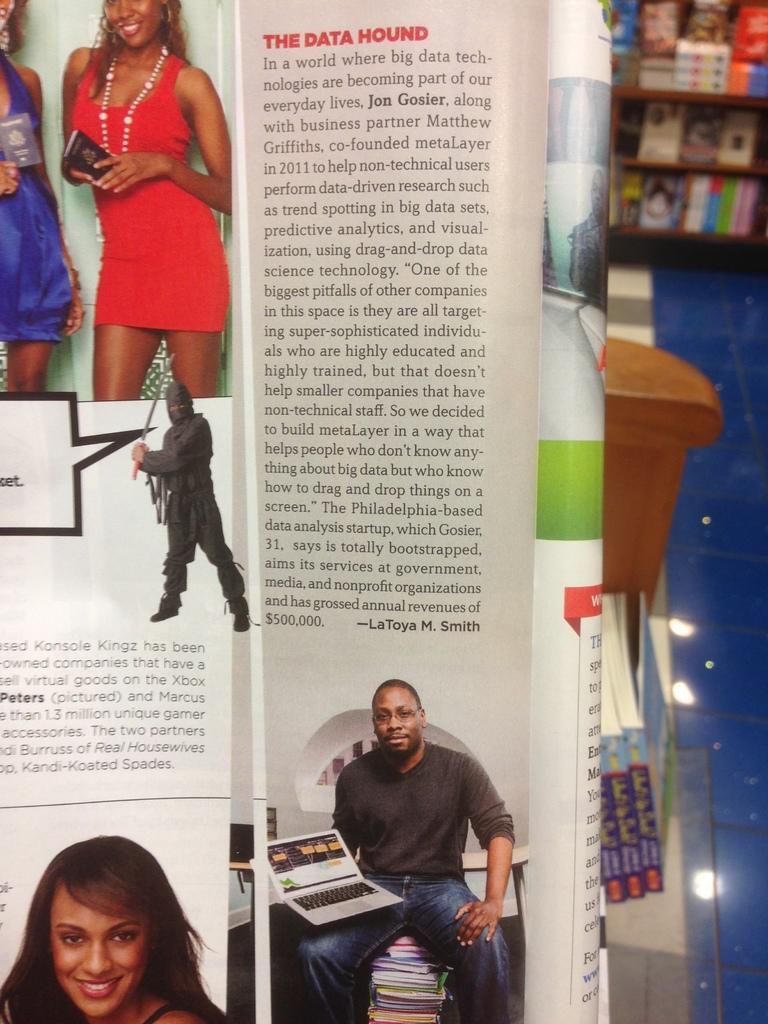Please provide a concise description of this image. In the foreground of this image, there is a book folded and in the background, there are books on the glass, floor and in the background, at the top, there are books in the shelf. 